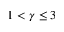<formula> <loc_0><loc_0><loc_500><loc_500>1 < \gamma \leq 3</formula> 